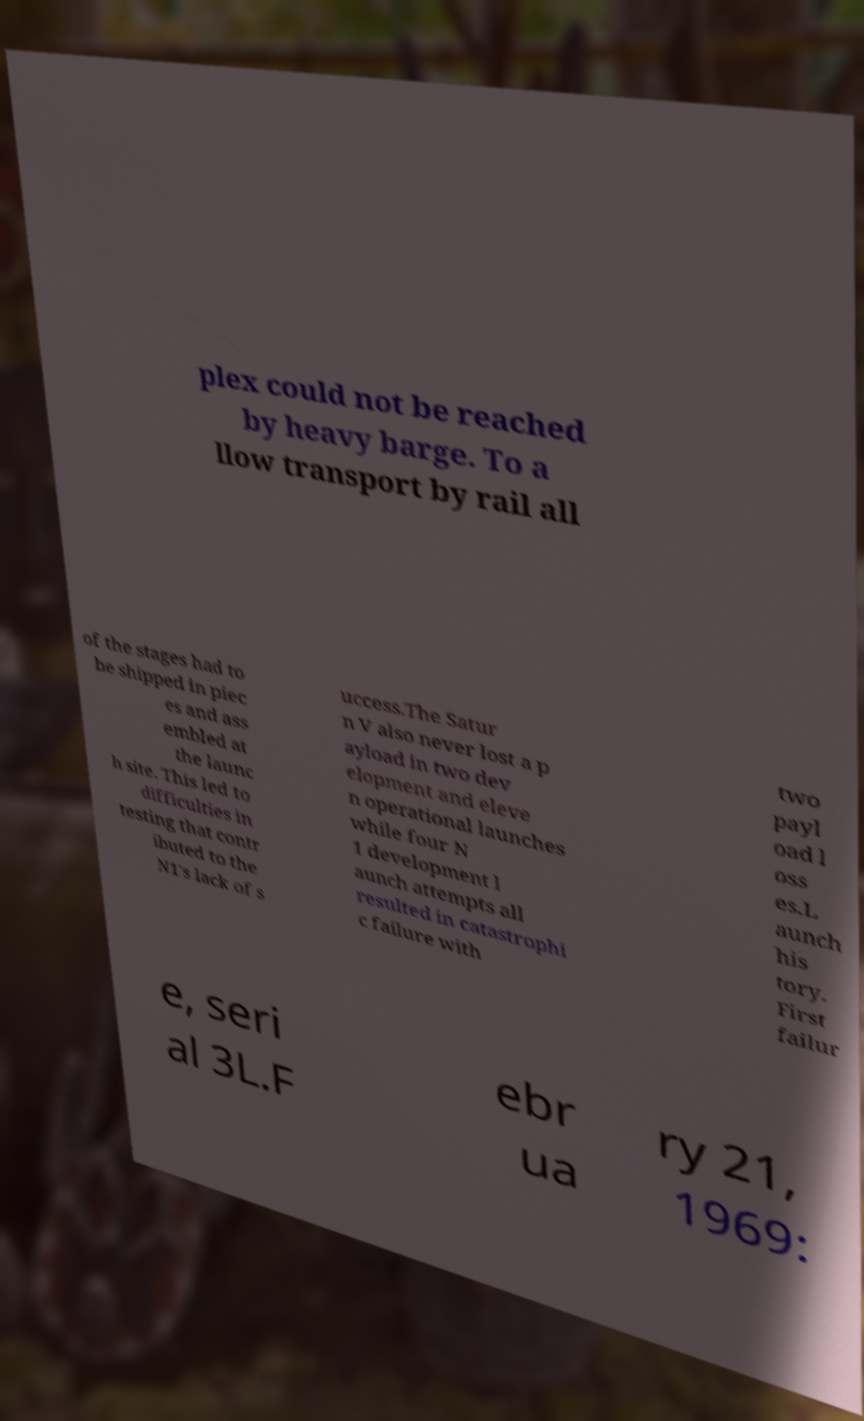Please identify and transcribe the text found in this image. plex could not be reached by heavy barge. To a llow transport by rail all of the stages had to be shipped in piec es and ass embled at the launc h site. This led to difficulties in testing that contr ibuted to the N1's lack of s uccess.The Satur n V also never lost a p ayload in two dev elopment and eleve n operational launches while four N 1 development l aunch attempts all resulted in catastrophi c failure with two payl oad l oss es.L aunch his tory. First failur e, seri al 3L.F ebr ua ry 21, 1969: 